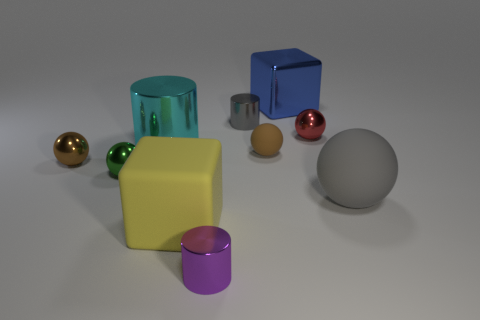Subtract all purple cylinders. How many cylinders are left? 2 Subtract all purple blocks. How many brown spheres are left? 2 Subtract 3 balls. How many balls are left? 2 Subtract all brown balls. How many balls are left? 3 Subtract all cylinders. How many objects are left? 7 Subtract all gray shiny objects. Subtract all large cyan objects. How many objects are left? 8 Add 8 tiny purple metal things. How many tiny purple metal things are left? 9 Add 6 gray shiny cylinders. How many gray shiny cylinders exist? 7 Subtract 0 yellow spheres. How many objects are left? 10 Subtract all gray blocks. Subtract all gray cylinders. How many blocks are left? 2 